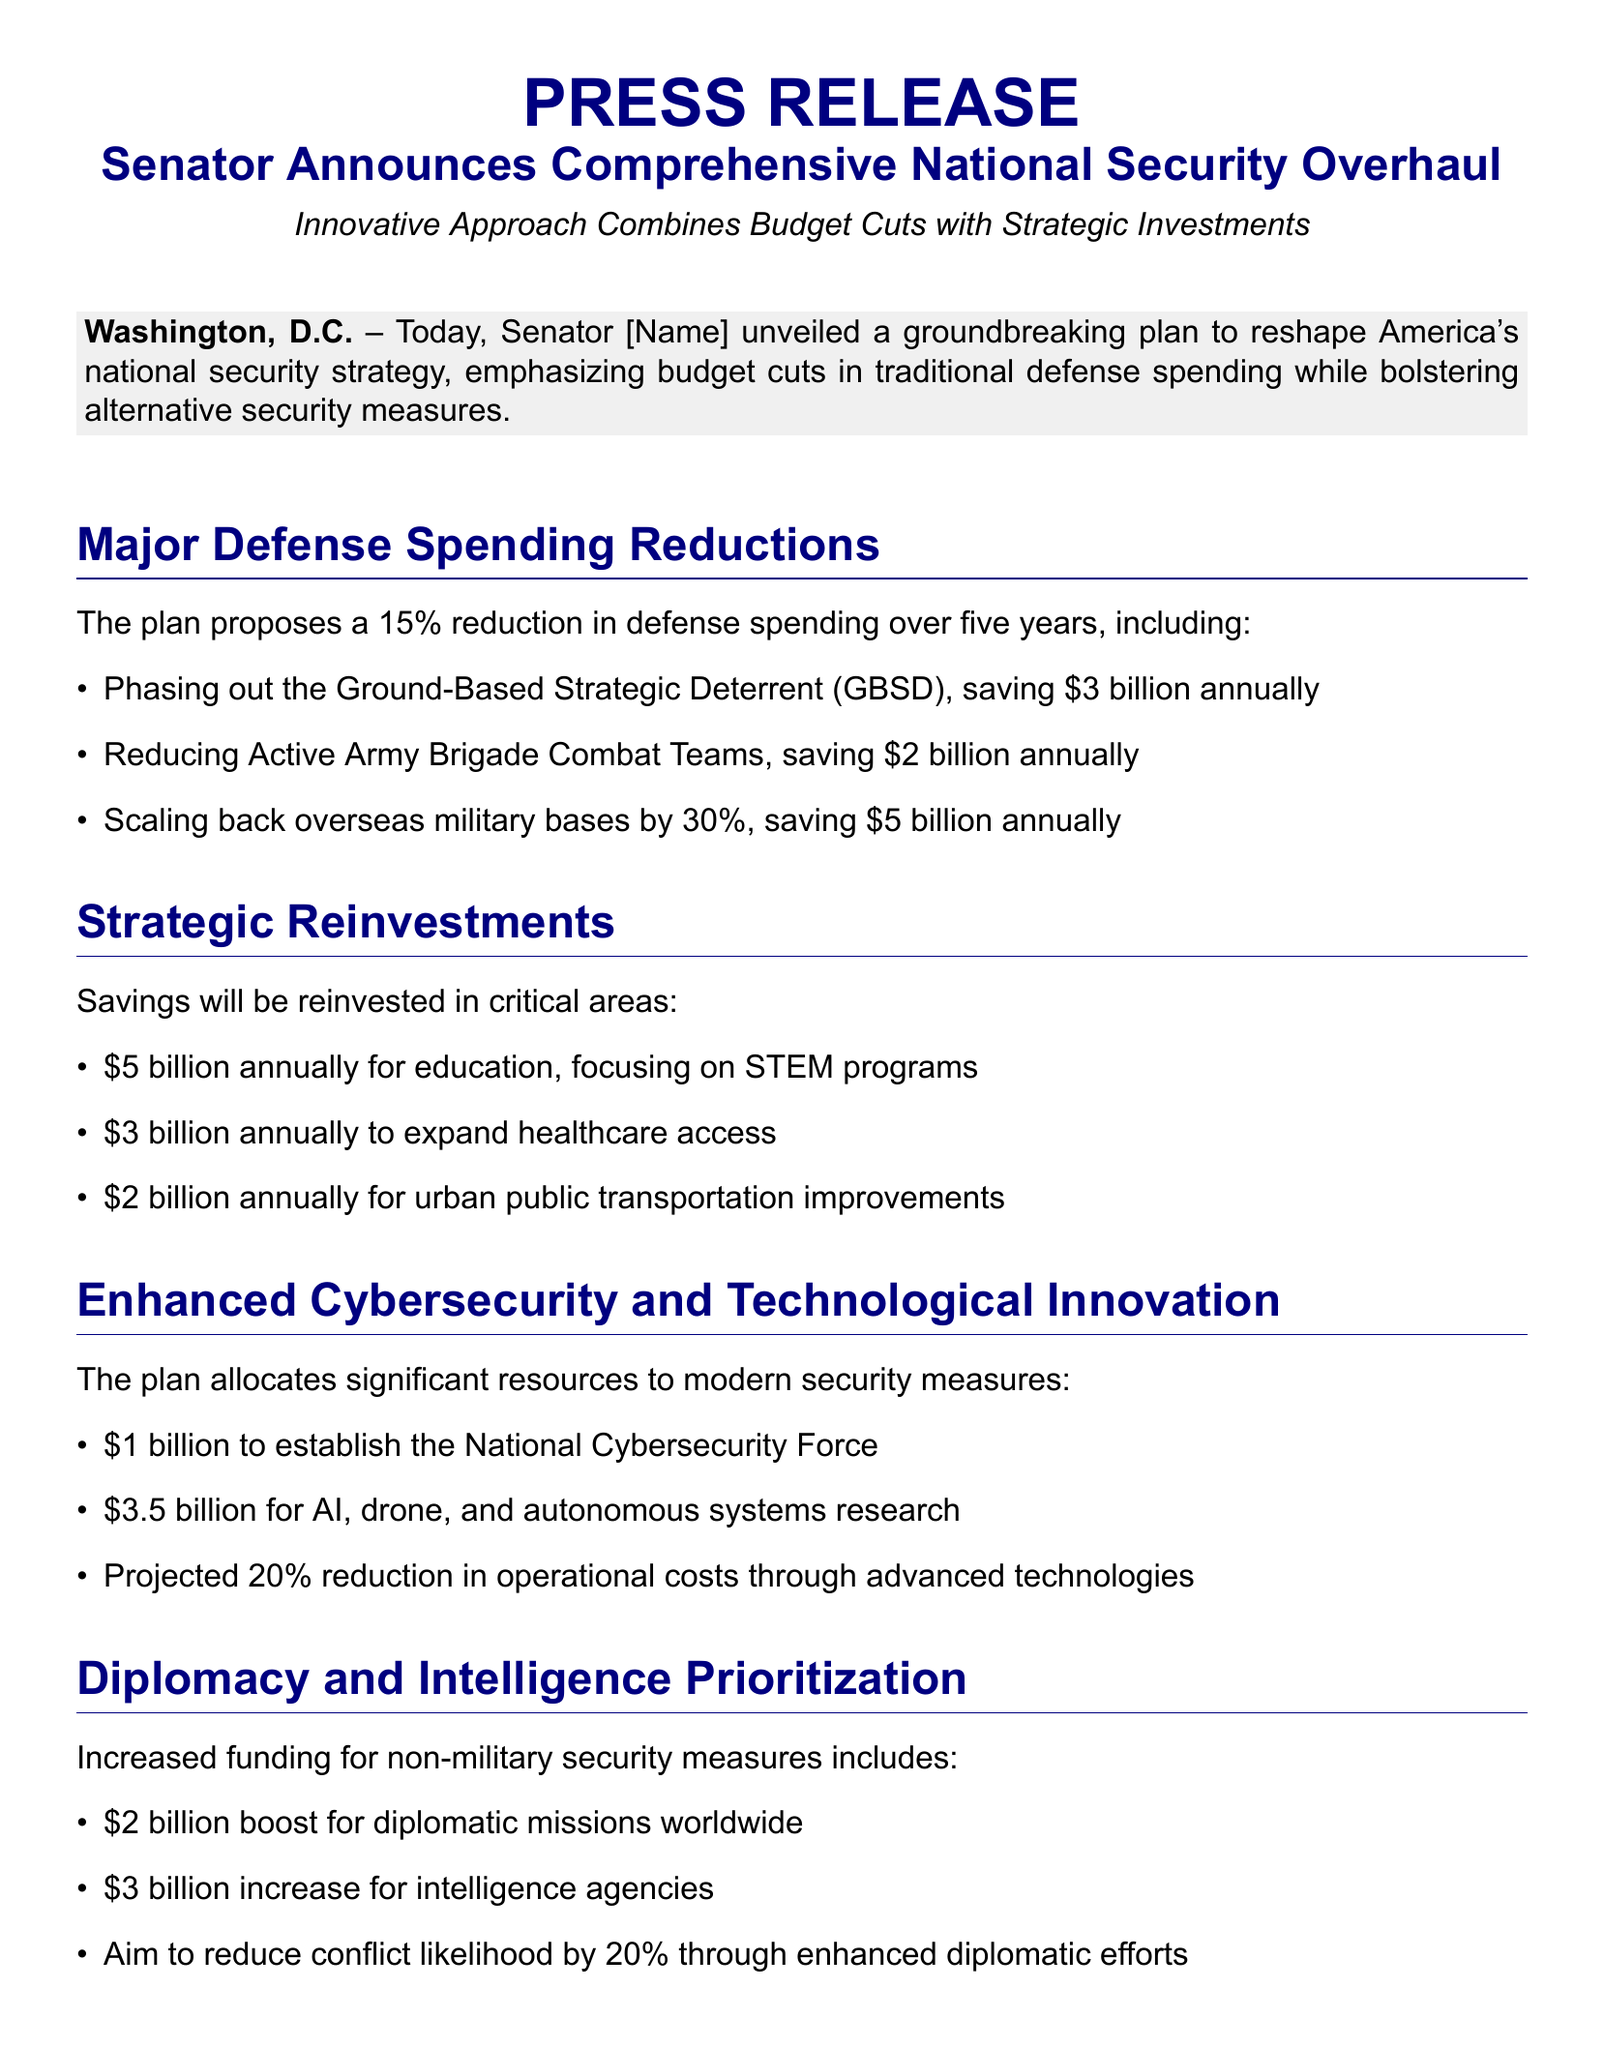What is the proposed reduction percentage in defense spending? The document states that the plan proposes a 15% reduction in defense spending over five years.
Answer: 15% How much annual savings is expected from phasing out the Ground-Based Strategic Deterrent? The document indicates that phasing out the Ground-Based Strategic Deterrent will save $3 billion annually.
Answer: $3 billion What amount is allocated for expanding healthcare access? The plan allocates $3 billion annually to expand healthcare access.
Answer: $3 billion What is the projected reduction in conflict likelihood through enhanced diplomatic efforts? According to the document, the aim is to reduce conflict likelihood by 20% through enhanced diplomatic efforts.
Answer: 20% What total funding increase is designated for intelligence agencies? The document specifies a $3 billion increase for intelligence agencies.
Answer: $3 billion Which area receives the largest annual investment from reinvestments? The largest annual investment from reinvestments is designated for education, focusing on STEM programs.
Answer: Education What initiative is allocated $1 billion for cybersecurity? The document mentions a $1 billion allocation to establish the National Cybersecurity Force.
Answer: National Cybersecurity Force What are the expected operational cost reductions through advanced technologies? The projected operational cost reduction is 20% through advanced technologies.
Answer: 20% What was the senator's statement regarding the national security plan? The senator stated that the plan represents a paradigm shift in how to approach national security.
Answer: Paradigm shift 